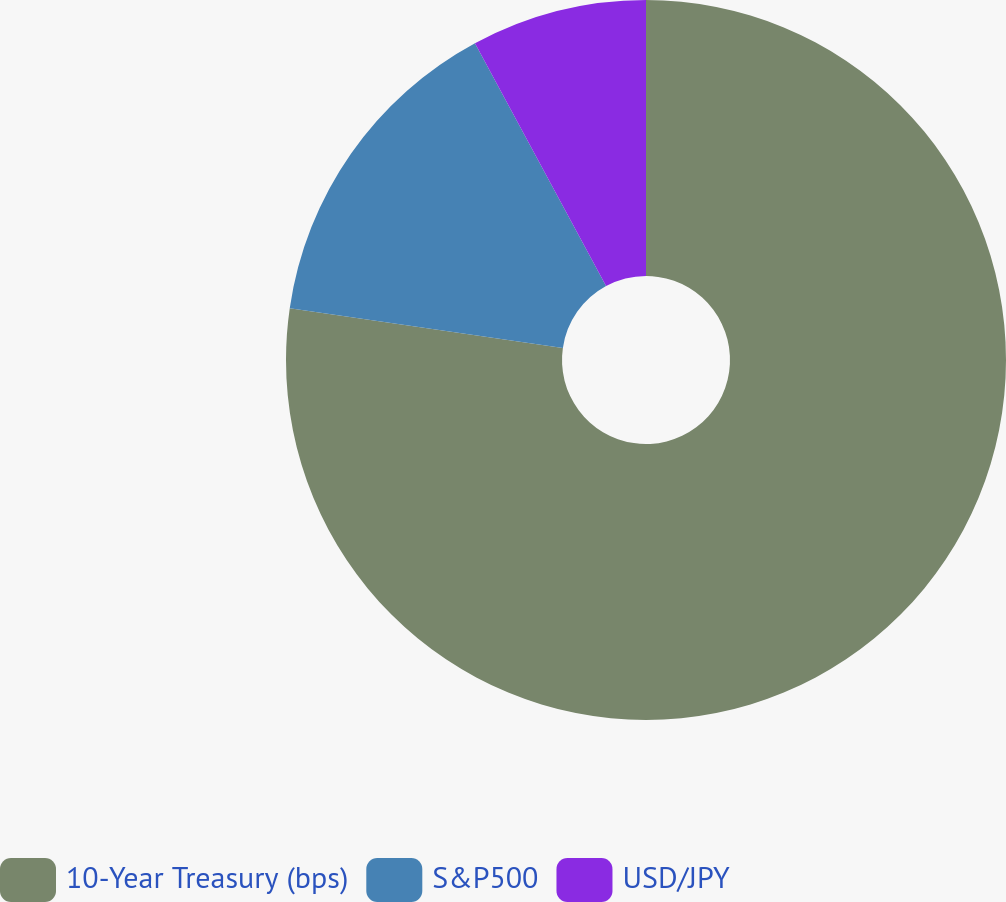Convert chart to OTSL. <chart><loc_0><loc_0><loc_500><loc_500><pie_chart><fcel>10-Year Treasury (bps)<fcel>S&P500<fcel>USD/JPY<nl><fcel>77.3%<fcel>14.82%<fcel>7.88%<nl></chart> 